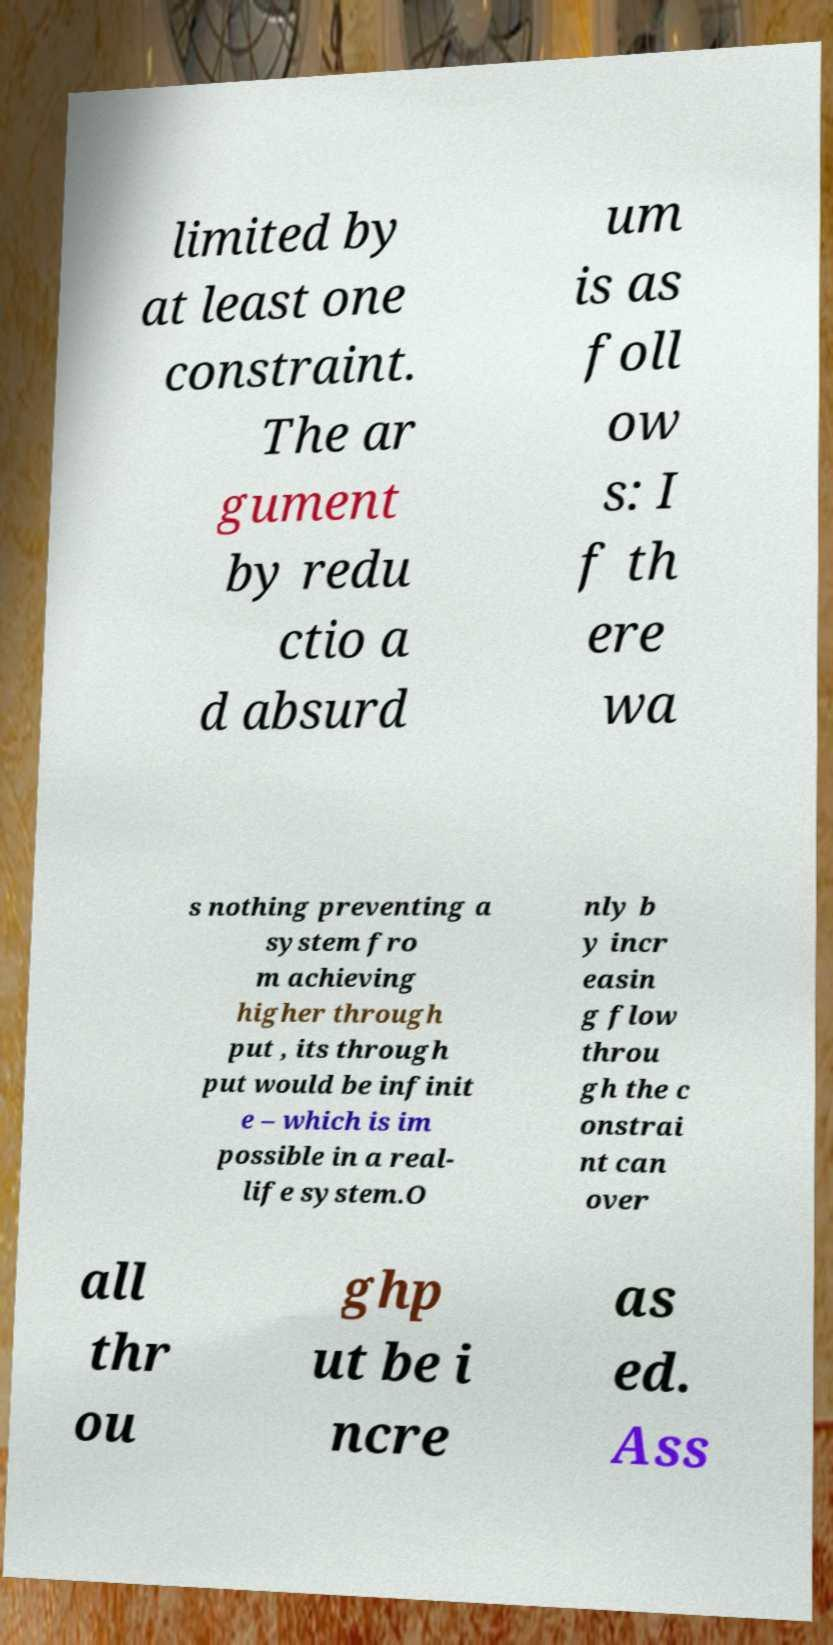Can you accurately transcribe the text from the provided image for me? limited by at least one constraint. The ar gument by redu ctio a d absurd um is as foll ow s: I f th ere wa s nothing preventing a system fro m achieving higher through put , its through put would be infinit e – which is im possible in a real- life system.O nly b y incr easin g flow throu gh the c onstrai nt can over all thr ou ghp ut be i ncre as ed. Ass 